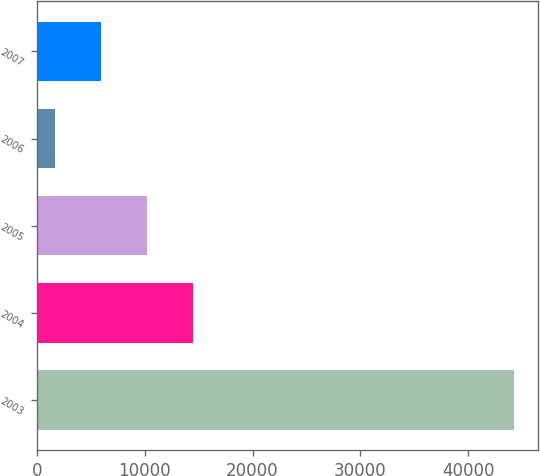Convert chart to OTSL. <chart><loc_0><loc_0><loc_500><loc_500><bar_chart><fcel>2003<fcel>2004<fcel>2005<fcel>2006<fcel>2007<nl><fcel>44236<fcel>14443.3<fcel>10187.2<fcel>1675<fcel>5931.1<nl></chart> 